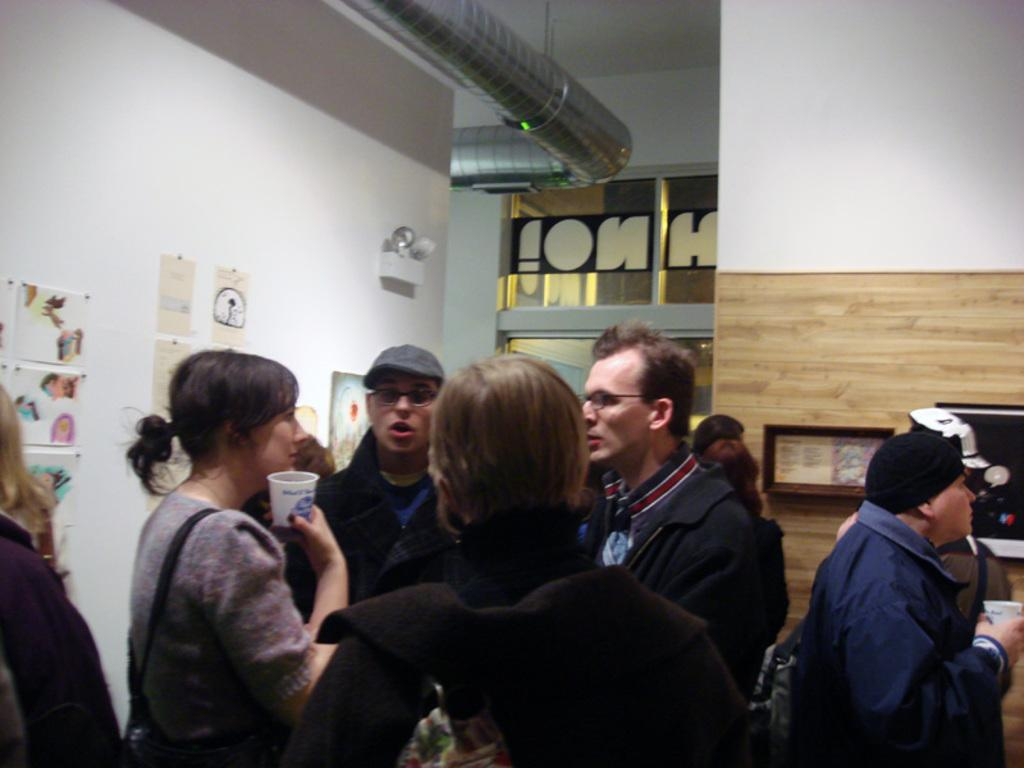How many people are present in the image? There are many people in the image. What accessories can be seen on some of the people? Some people are wearing caps and specs. What are some people holding in the image? Some people are holding cups. What can be seen on the wall in the image? There are photo frames and other things on the wall. Can you describe the earthquake happening in the image? There is no earthquake present in the image. What type of waves can be seen crashing on the shore in the image? There is no shore or waves present in the image. 